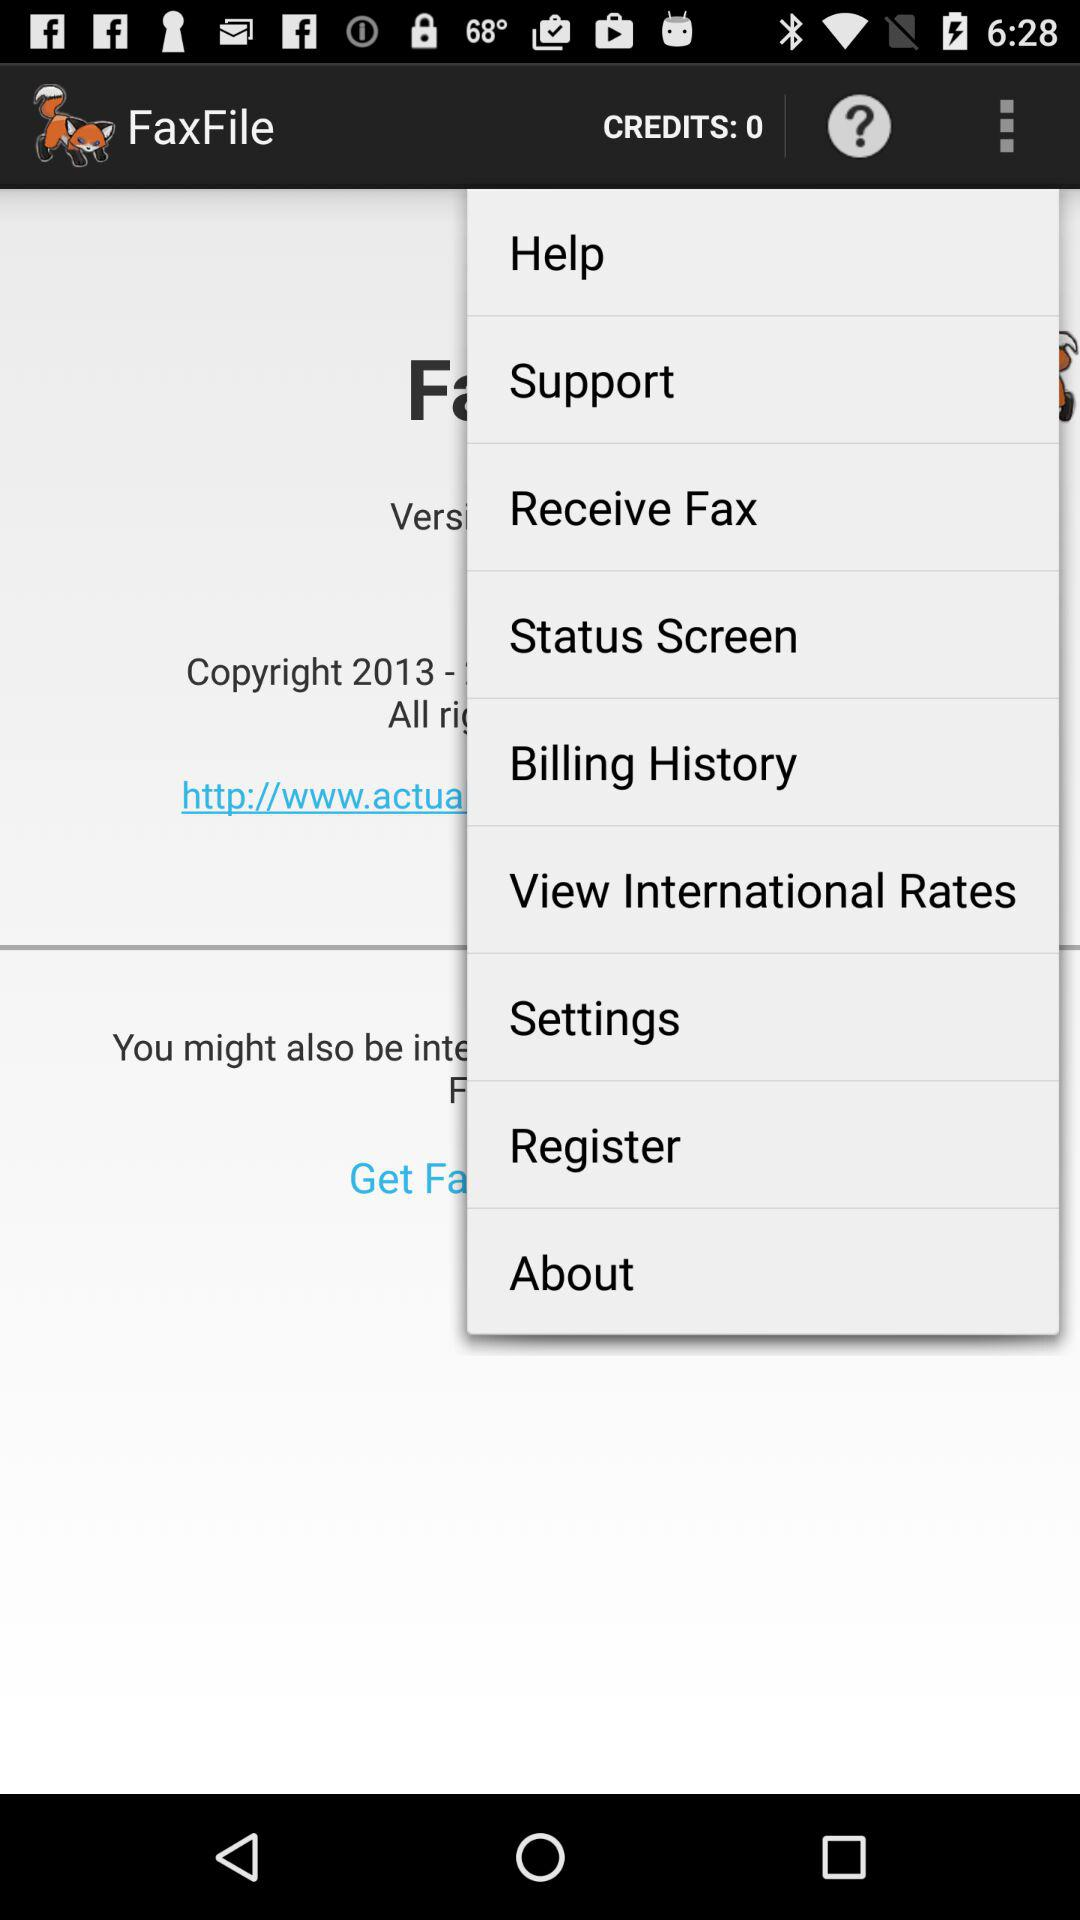What is the application name? The application name is "FaxFile". 